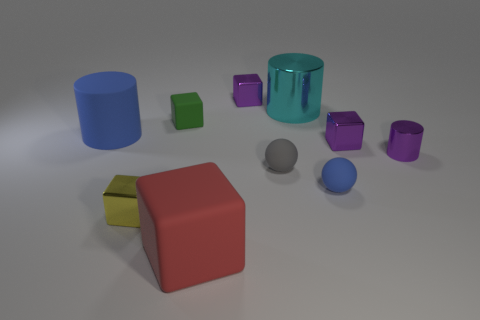There is a tiny rubber object that is behind the small gray rubber thing; is it the same shape as the large cyan object? The tiny rubber object behind the small gray item is a sphere, which differs from the large cyan object, which is cylindrical. 